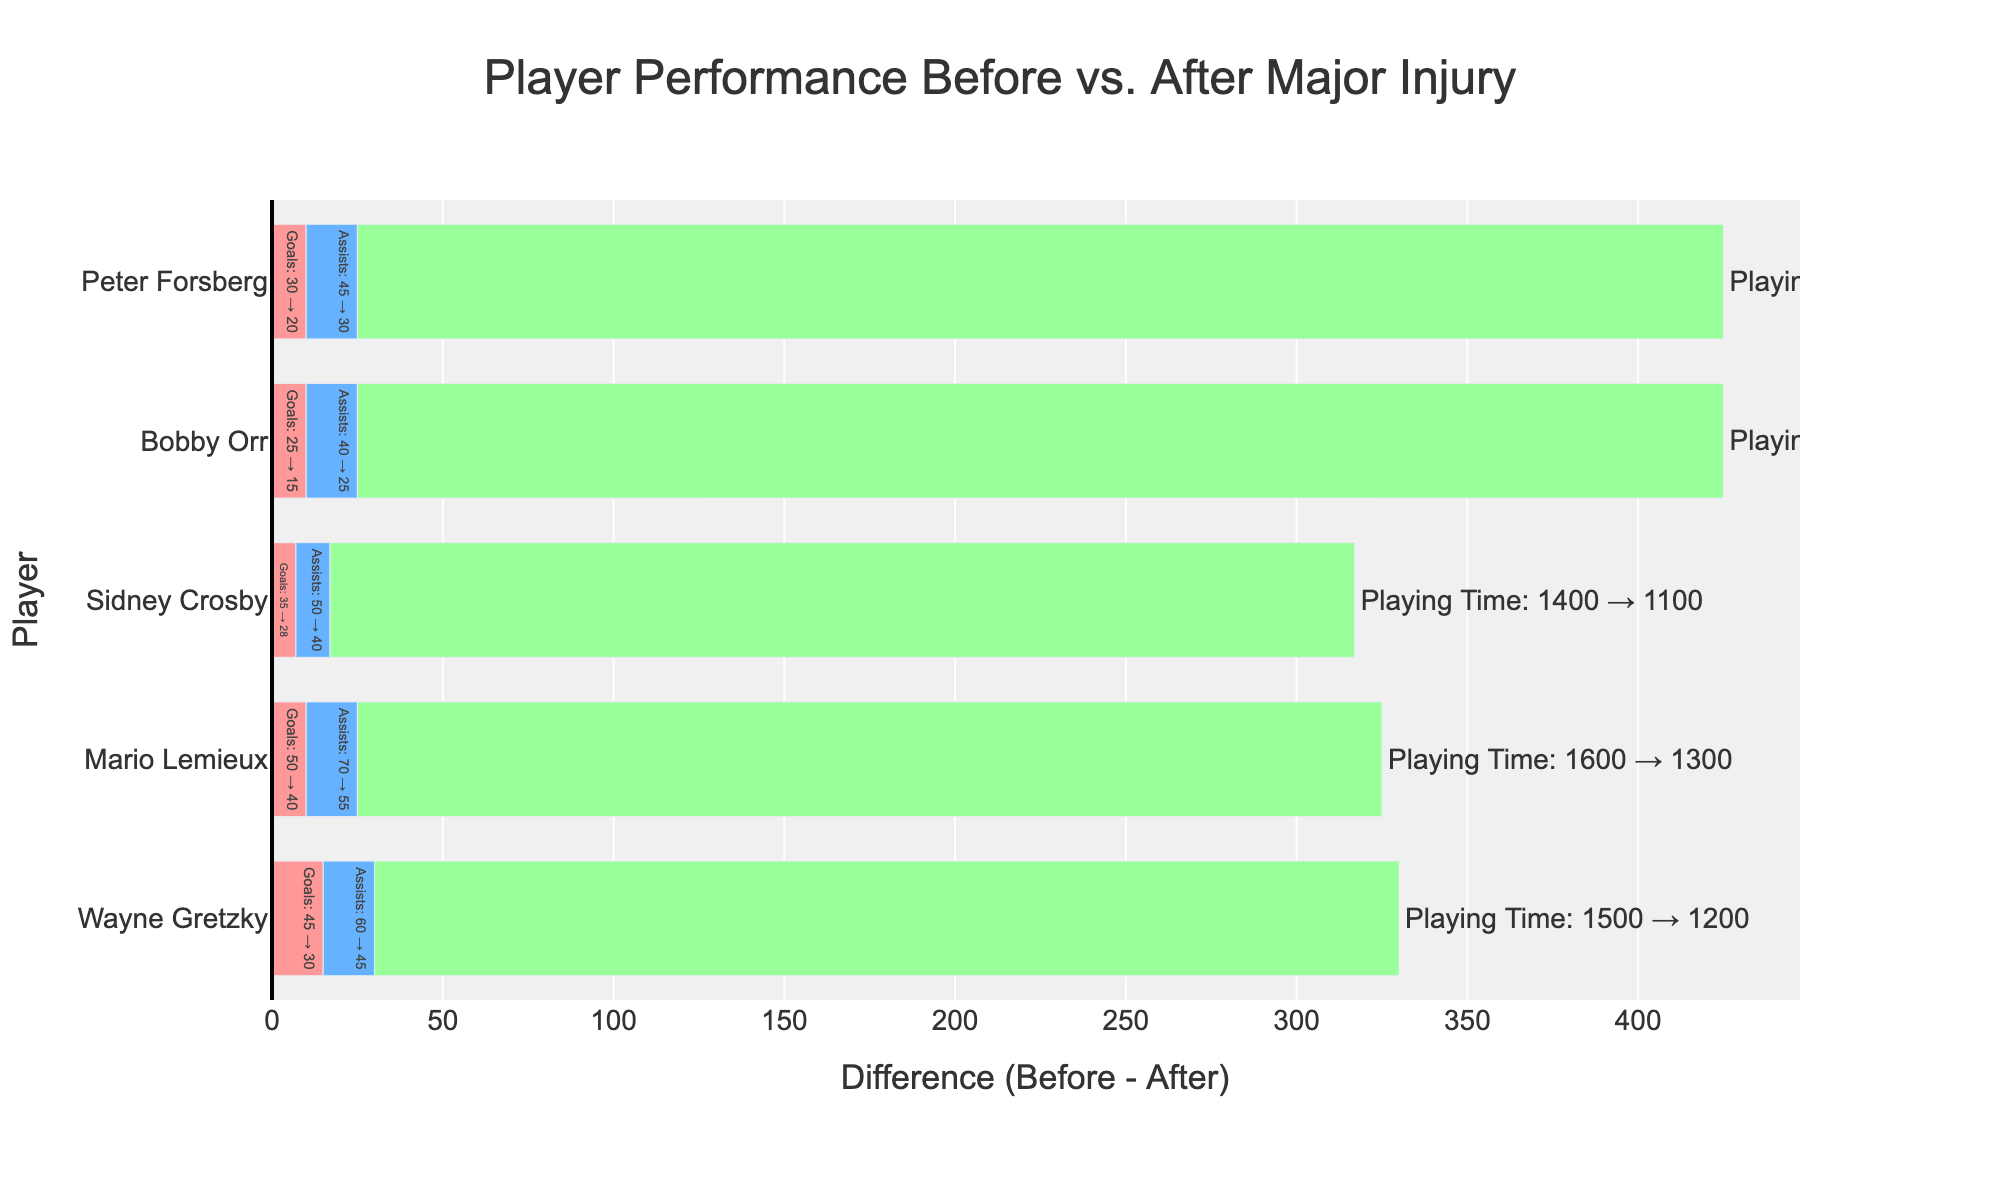What is the total decline in goals for all players after their major injuries? Sum the differences in goals for each player: Wayne Gretzky (45 - 30=15), Mario Lemieux (50 - 40=10), Sidney Crosby (35 - 28=7), Bobby Orr (25 - 15=10), and Peter Forsberg (30 - 20=10). Thus, the total decline is 15 + 10 + 7 + 10 + 10 = 52
Answer: 52 Which player experienced the least decline in assists after their major injury? Compare the decline in assists for each player: Wayne Gretzky (60 - 45=15), Mario Lemieux (70 - 55=15), Sidney Crosby (50 - 40=10), Bobby Orr (40 - 25=15), and Peter Forsberg (45 - 30=15). The smallest decline is 10 (Sidney Crosby)
Answer: Sidney Crosby Who had the biggest drop in playing time after a major injury? Check the decline in playing time for each player: Wayne Gretzky (1500 - 1200=300), Mario Lemieux (1600 - 1300=300), Sidney Crosby (1400 - 1100=300), Bobby Orr (1300 - 900=400), and Peter Forsberg (1400 - 1000=400). Bobby Orr and Peter Forsberg both had the largest drop of 400 minutes
Answer: Bobby Orr and Peter Forsberg What is the average decline in assists across all players? Calculate the decline for each player, sum them up and divide by the number of players: (Wayne Gretzky (15) + Mario Lemieux (15) + Sidney Crosby (10) + Bobby Orr (15) + Peter Forsberg (15)) / 5. Thus, the average decline is (15 + 15 + 10 + 15 + 15) / 5 = 14
Answer: 14 Which player had the highest number of combined goal and assist declines after their injury? Calculate the combined decline for both metrics for each player: Wayne Gretzky (15 goals + 15 assists = 30), Mario Lemieux (10 goals + 15 assists = 25), Sidney Crosby (7 goals + 10 assists = 17), Bobby Orr (10 goals + 15 assists = 25), and Peter Forsberg (10 goals + 15 assists = 25). Wayne Gretzky has the highest combined decline
Answer: Wayne Gretzky What color bars represent the decline in playing time? Identify the color associated with playing time bars, which is visible in the figure
Answer: green 